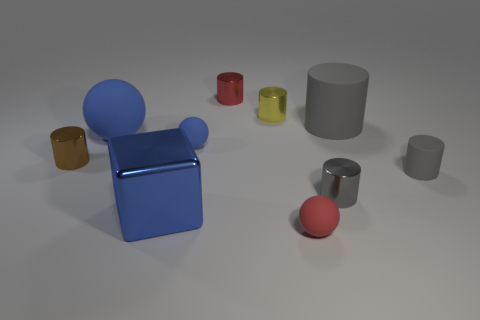What is the color of the other big thing that is the same shape as the brown object? The object that shares the same shape as the brown cube is a large blue cube. 